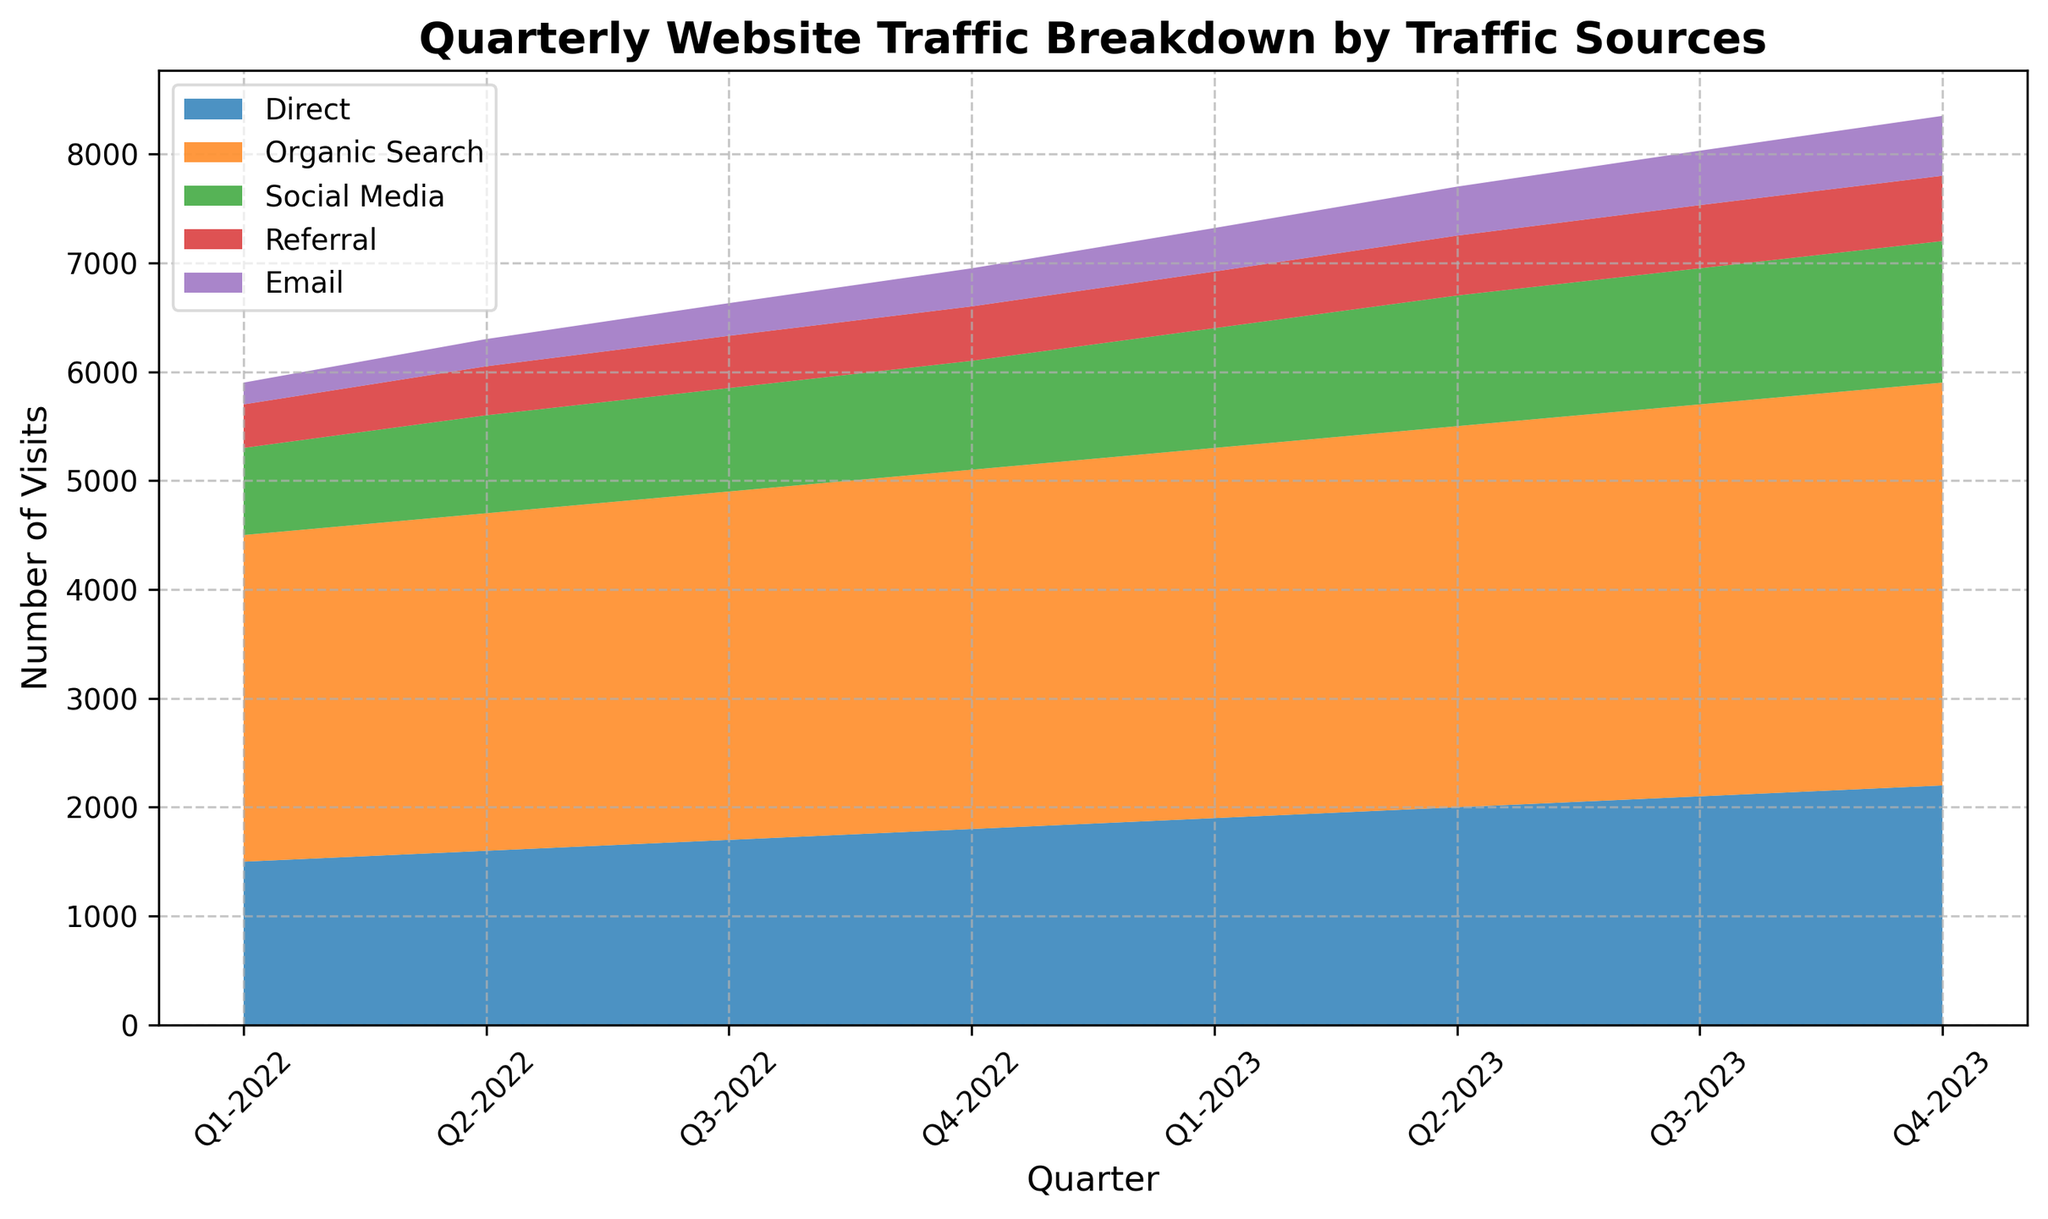what are the total visits in Q1-2023 from all traffic sources To find the total visits in Q1-2023, sum the values from all traffic sources for that quarter. These values are 1900 (Direct), 3400 (Organic Search), 1100 (Social Media), 520 (Referral), and 400 (Email). Adding them up gives 1900 + 3400 + 1100 + 520 + 400 = 7320
Answer: 7320 Which traffic source had the highest number of visits in Q4-2023 By looking at the top-most part of the area chart for Q4-2023, we observe that Organic Search contributes the majority share. The data value for Organic Search in Q4-2023 is 3700, which is the highest among all other sources.
Answer: Organic Search What is the trend for Social Media traffic from Q1-2022 to Q4-2023 To understand the trend, observe the area attributed to Social Media from Q1-2022 to Q4-2023. The height slightly increases each quarter from 800 in Q1-2022 to 1300 in Q4-2023, indicating an upward trend over time.
Answer: Increasing How does the Q3-2023 Email traffic compare with Q3-2022 Email traffic To compare the Email traffic between Q3-2023 and Q3-2022, look at the heights of the section portraying Email in the respective quarters. The value in Q3-2022 is 300, while in Q3-2023 it is 500. Thus, Q3-2023 Email traffic is greater.
Answer: Q3-2023 is greater How much did Organic Search traffic increase from Q1-2022 to Q4-2023 First, identify the Organic Search values for Q1-2022 (3000) and Q4-2023 (3700). The increase can be calculated as 3700 - 3000 = 700.
Answer: 700 What is the combined traffic for Social Media and Referral in Q2-2023 Look at the values of Social Media (1200) and Referral (550) for Q2-2023 and sum them up. So, 1200 + 550 = 1750
Answer: 1750 Has the total website traffic increased every quarter To determine this, check the overall height of the stacked regions for each subsequent quarter and ensure the total height consistently increases each quarter. From the values, total traffic indeed grows every quarter.
Answer: Yes What's the proportional contribution of Email traffic in Q4-2022 to the total traffic for that quarter Sum all traffic sources for Q4-2022: 1800 (Direct), 3300 (Organic Search), 1000 (Social Media), 500 (Referral), and 350 (Email) to get the total: 1800 + 3300 + 1000 + 500 + 350 = 6950. The Email portion is 350. Therefore, the proportion is 350/6950.
Answer: 5.04% Between Direct and Referral, which source showed a consistent increase every quarter Look at the data trends for Direct and Referral traffic. Direct traffic consistently rises from 1500 in Q1-2022 to 2200 in Q4-2023, while Referral also increases from 400 to 600 during the same period. Both show consistent increases.
Answer: Both By how much did the Referral traffic in Q4-2023 exceed Q1-2022’s Referral traffic The Referral traffic in Q4-2023 is 600, and in Q1-2022 it’s 400. The difference is 600 - 400 = 200.
Answer: 200 